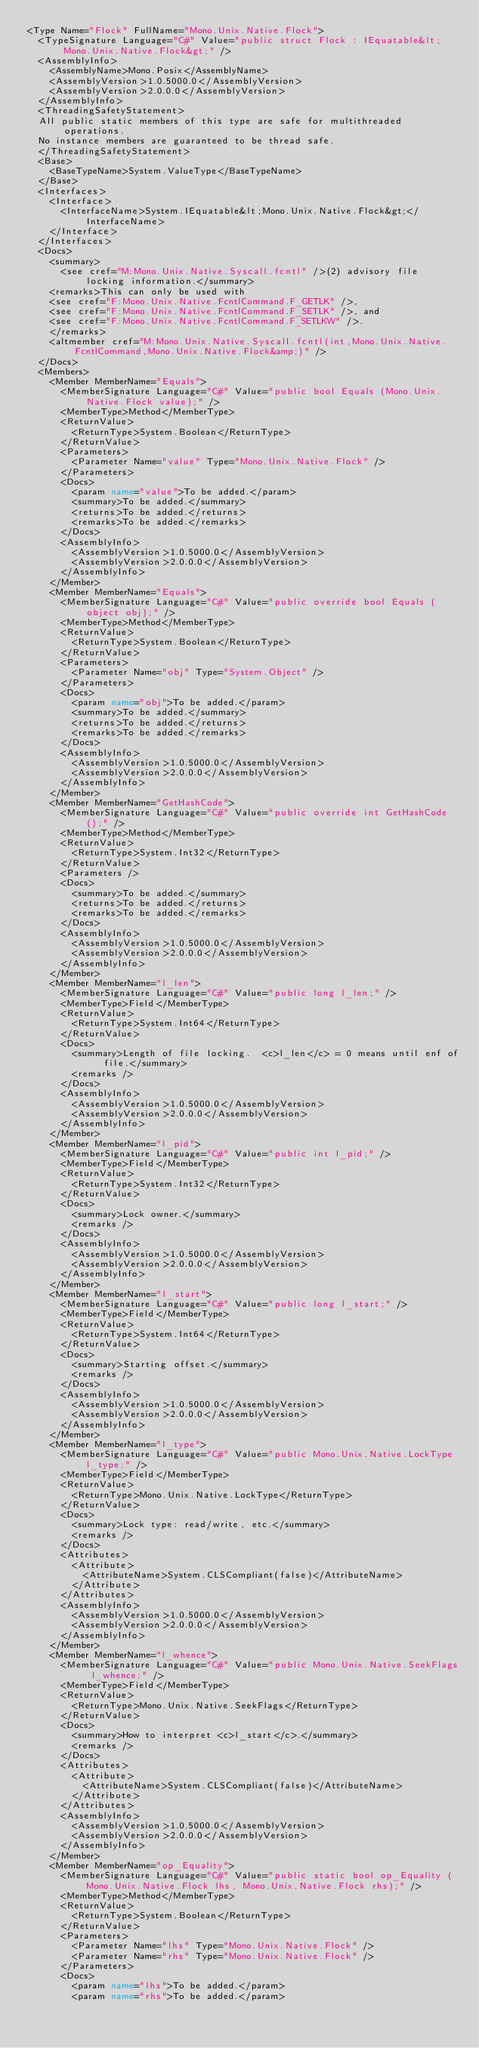Convert code to text. <code><loc_0><loc_0><loc_500><loc_500><_XML_><Type Name="Flock" FullName="Mono.Unix.Native.Flock">
  <TypeSignature Language="C#" Value="public struct Flock : IEquatable&lt;Mono.Unix.Native.Flock&gt;" />
  <AssemblyInfo>
    <AssemblyName>Mono.Posix</AssemblyName>
    <AssemblyVersion>1.0.5000.0</AssemblyVersion>
    <AssemblyVersion>2.0.0.0</AssemblyVersion>
  </AssemblyInfo>
  <ThreadingSafetyStatement>
  All public static members of this type are safe for multithreaded operations. 
  No instance members are guaranteed to be thread safe.
  </ThreadingSafetyStatement>
  <Base>
    <BaseTypeName>System.ValueType</BaseTypeName>
  </Base>
  <Interfaces>
    <Interface>
      <InterfaceName>System.IEquatable&lt;Mono.Unix.Native.Flock&gt;</InterfaceName>
    </Interface>
  </Interfaces>
  <Docs>
    <summary>
      <see cref="M:Mono.Unix.Native.Syscall.fcntl" />(2) advisory file locking information.</summary>
    <remarks>This can only be used with 
    <see cref="F:Mono.Unix.Native.FcntlCommand.F_GETLK" />, 
    <see cref="F:Mono.Unix.Native.FcntlCommand.F_SETLK" />, and
    <see cref="F:Mono.Unix.Native.FcntlCommand.F_SETLKW" />.
    </remarks>
    <altmember cref="M:Mono.Unix.Native.Syscall.fcntl(int,Mono.Unix.Native.FcntlCommand,Mono.Unix.Native.Flock&amp;)" />
  </Docs>
  <Members>
    <Member MemberName="Equals">
      <MemberSignature Language="C#" Value="public bool Equals (Mono.Unix.Native.Flock value);" />
      <MemberType>Method</MemberType>
      <ReturnValue>
        <ReturnType>System.Boolean</ReturnType>
      </ReturnValue>
      <Parameters>
        <Parameter Name="value" Type="Mono.Unix.Native.Flock" />
      </Parameters>
      <Docs>
        <param name="value">To be added.</param>
        <summary>To be added.</summary>
        <returns>To be added.</returns>
        <remarks>To be added.</remarks>
      </Docs>
      <AssemblyInfo>
        <AssemblyVersion>1.0.5000.0</AssemblyVersion>
        <AssemblyVersion>2.0.0.0</AssemblyVersion>
      </AssemblyInfo>
    </Member>
    <Member MemberName="Equals">
      <MemberSignature Language="C#" Value="public override bool Equals (object obj);" />
      <MemberType>Method</MemberType>
      <ReturnValue>
        <ReturnType>System.Boolean</ReturnType>
      </ReturnValue>
      <Parameters>
        <Parameter Name="obj" Type="System.Object" />
      </Parameters>
      <Docs>
        <param name="obj">To be added.</param>
        <summary>To be added.</summary>
        <returns>To be added.</returns>
        <remarks>To be added.</remarks>
      </Docs>
      <AssemblyInfo>
        <AssemblyVersion>1.0.5000.0</AssemblyVersion>
        <AssemblyVersion>2.0.0.0</AssemblyVersion>
      </AssemblyInfo>
    </Member>
    <Member MemberName="GetHashCode">
      <MemberSignature Language="C#" Value="public override int GetHashCode ();" />
      <MemberType>Method</MemberType>
      <ReturnValue>
        <ReturnType>System.Int32</ReturnType>
      </ReturnValue>
      <Parameters />
      <Docs>
        <summary>To be added.</summary>
        <returns>To be added.</returns>
        <remarks>To be added.</remarks>
      </Docs>
      <AssemblyInfo>
        <AssemblyVersion>1.0.5000.0</AssemblyVersion>
        <AssemblyVersion>2.0.0.0</AssemblyVersion>
      </AssemblyInfo>
    </Member>
    <Member MemberName="l_len">
      <MemberSignature Language="C#" Value="public long l_len;" />
      <MemberType>Field</MemberType>
      <ReturnValue>
        <ReturnType>System.Int64</ReturnType>
      </ReturnValue>
      <Docs>
        <summary>Length of file locking.  <c>l_len</c> = 0 means until enf of file.</summary>
        <remarks />
      </Docs>
      <AssemblyInfo>
        <AssemblyVersion>1.0.5000.0</AssemblyVersion>
        <AssemblyVersion>2.0.0.0</AssemblyVersion>
      </AssemblyInfo>
    </Member>
    <Member MemberName="l_pid">
      <MemberSignature Language="C#" Value="public int l_pid;" />
      <MemberType>Field</MemberType>
      <ReturnValue>
        <ReturnType>System.Int32</ReturnType>
      </ReturnValue>
      <Docs>
        <summary>Lock owner.</summary>
        <remarks />
      </Docs>
      <AssemblyInfo>
        <AssemblyVersion>1.0.5000.0</AssemblyVersion>
        <AssemblyVersion>2.0.0.0</AssemblyVersion>
      </AssemblyInfo>
    </Member>
    <Member MemberName="l_start">
      <MemberSignature Language="C#" Value="public long l_start;" />
      <MemberType>Field</MemberType>
      <ReturnValue>
        <ReturnType>System.Int64</ReturnType>
      </ReturnValue>
      <Docs>
        <summary>Starting offset.</summary>
        <remarks />
      </Docs>
      <AssemblyInfo>
        <AssemblyVersion>1.0.5000.0</AssemblyVersion>
        <AssemblyVersion>2.0.0.0</AssemblyVersion>
      </AssemblyInfo>
    </Member>
    <Member MemberName="l_type">
      <MemberSignature Language="C#" Value="public Mono.Unix.Native.LockType l_type;" />
      <MemberType>Field</MemberType>
      <ReturnValue>
        <ReturnType>Mono.Unix.Native.LockType</ReturnType>
      </ReturnValue>
      <Docs>
        <summary>Lock type: read/write, etc.</summary>
        <remarks />
      </Docs>
      <Attributes>
        <Attribute>
          <AttributeName>System.CLSCompliant(false)</AttributeName>
        </Attribute>
      </Attributes>
      <AssemblyInfo>
        <AssemblyVersion>1.0.5000.0</AssemblyVersion>
        <AssemblyVersion>2.0.0.0</AssemblyVersion>
      </AssemblyInfo>
    </Member>
    <Member MemberName="l_whence">
      <MemberSignature Language="C#" Value="public Mono.Unix.Native.SeekFlags l_whence;" />
      <MemberType>Field</MemberType>
      <ReturnValue>
        <ReturnType>Mono.Unix.Native.SeekFlags</ReturnType>
      </ReturnValue>
      <Docs>
        <summary>How to interpret <c>l_start</c>.</summary>
        <remarks />
      </Docs>
      <Attributes>
        <Attribute>
          <AttributeName>System.CLSCompliant(false)</AttributeName>
        </Attribute>
      </Attributes>
      <AssemblyInfo>
        <AssemblyVersion>1.0.5000.0</AssemblyVersion>
        <AssemblyVersion>2.0.0.0</AssemblyVersion>
      </AssemblyInfo>
    </Member>
    <Member MemberName="op_Equality">
      <MemberSignature Language="C#" Value="public static bool op_Equality (Mono.Unix.Native.Flock lhs, Mono.Unix.Native.Flock rhs);" />
      <MemberType>Method</MemberType>
      <ReturnValue>
        <ReturnType>System.Boolean</ReturnType>
      </ReturnValue>
      <Parameters>
        <Parameter Name="lhs" Type="Mono.Unix.Native.Flock" />
        <Parameter Name="rhs" Type="Mono.Unix.Native.Flock" />
      </Parameters>
      <Docs>
        <param name="lhs">To be added.</param>
        <param name="rhs">To be added.</param></code> 